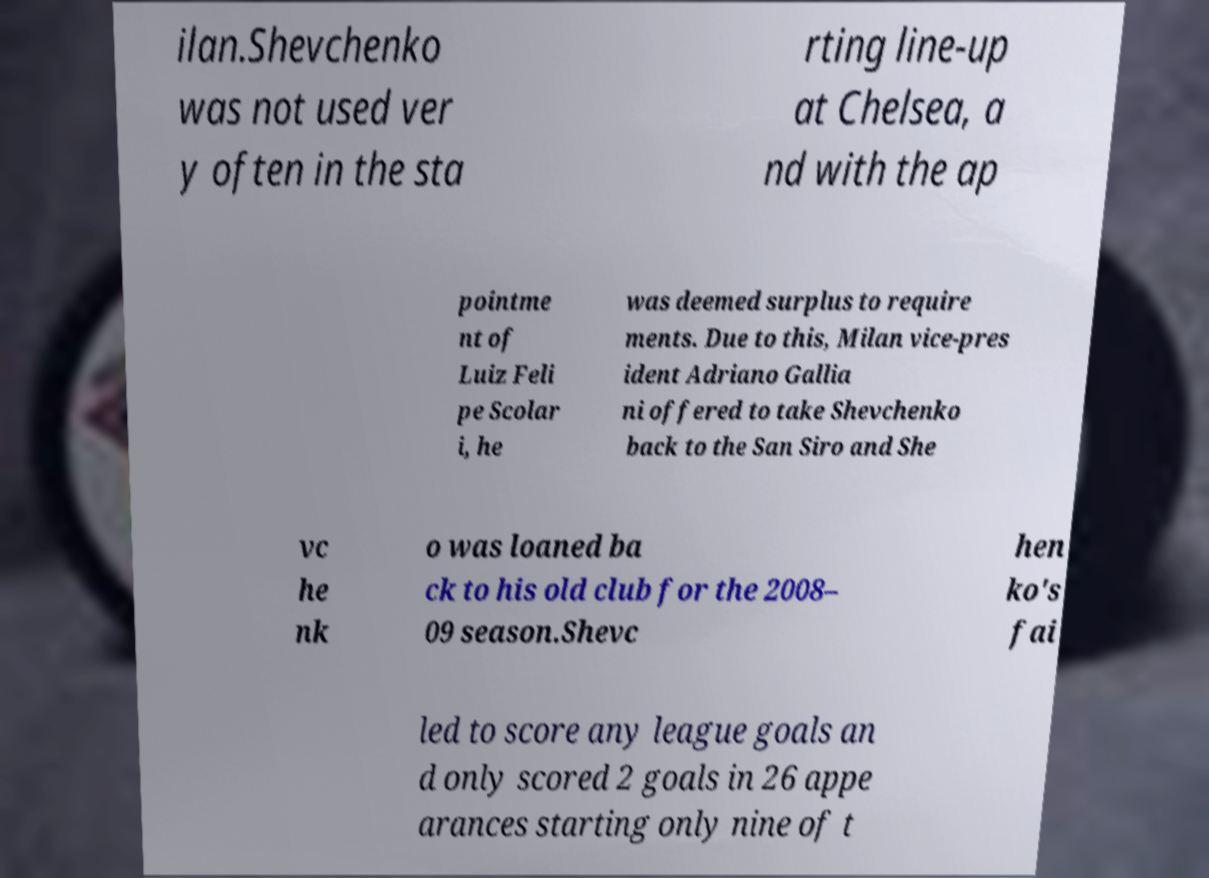For documentation purposes, I need the text within this image transcribed. Could you provide that? ilan.Shevchenko was not used ver y often in the sta rting line-up at Chelsea, a nd with the ap pointme nt of Luiz Feli pe Scolar i, he was deemed surplus to require ments. Due to this, Milan vice-pres ident Adriano Gallia ni offered to take Shevchenko back to the San Siro and She vc he nk o was loaned ba ck to his old club for the 2008– 09 season.Shevc hen ko's fai led to score any league goals an d only scored 2 goals in 26 appe arances starting only nine of t 